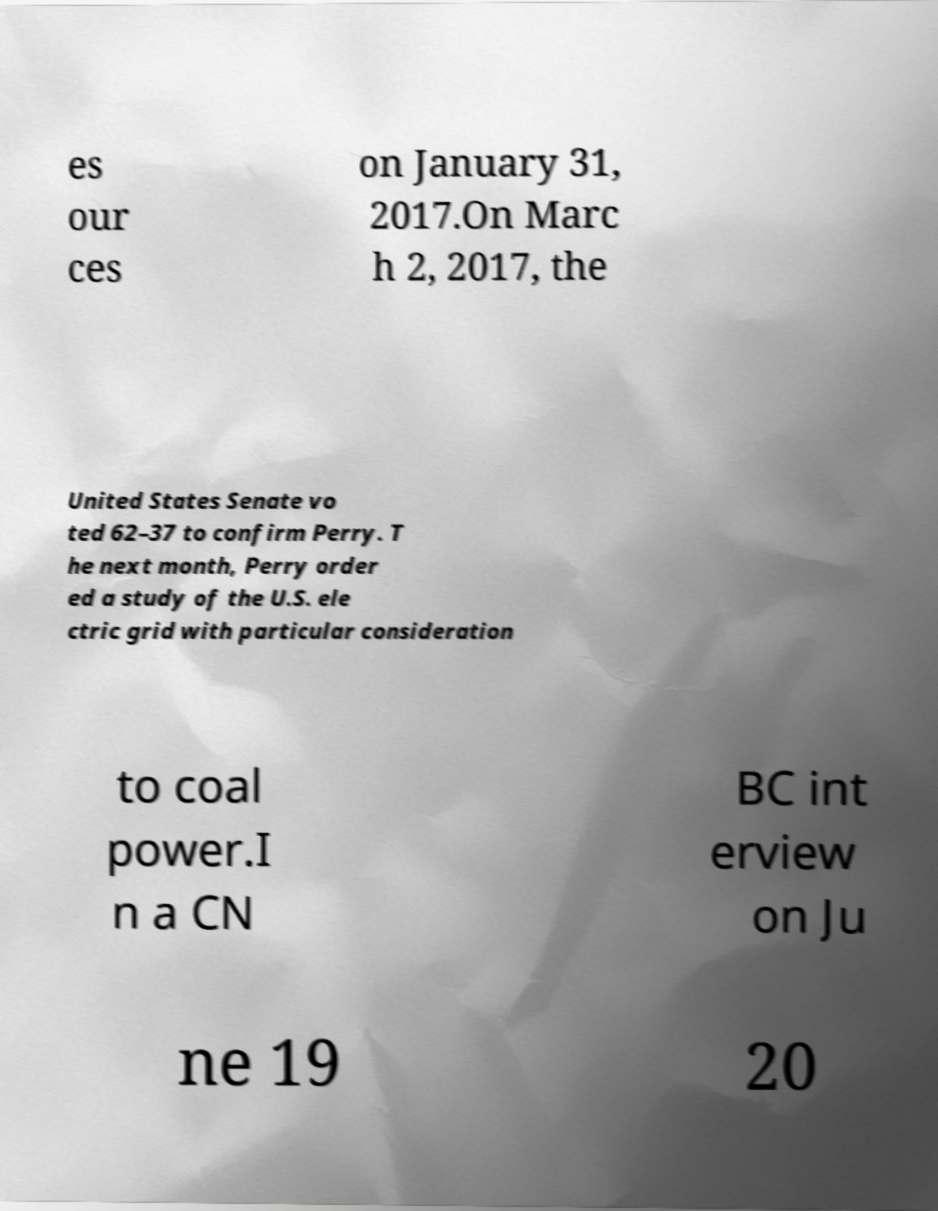Could you extract and type out the text from this image? es our ces on January 31, 2017.On Marc h 2, 2017, the United States Senate vo ted 62–37 to confirm Perry. T he next month, Perry order ed a study of the U.S. ele ctric grid with particular consideration to coal power.I n a CN BC int erview on Ju ne 19 20 